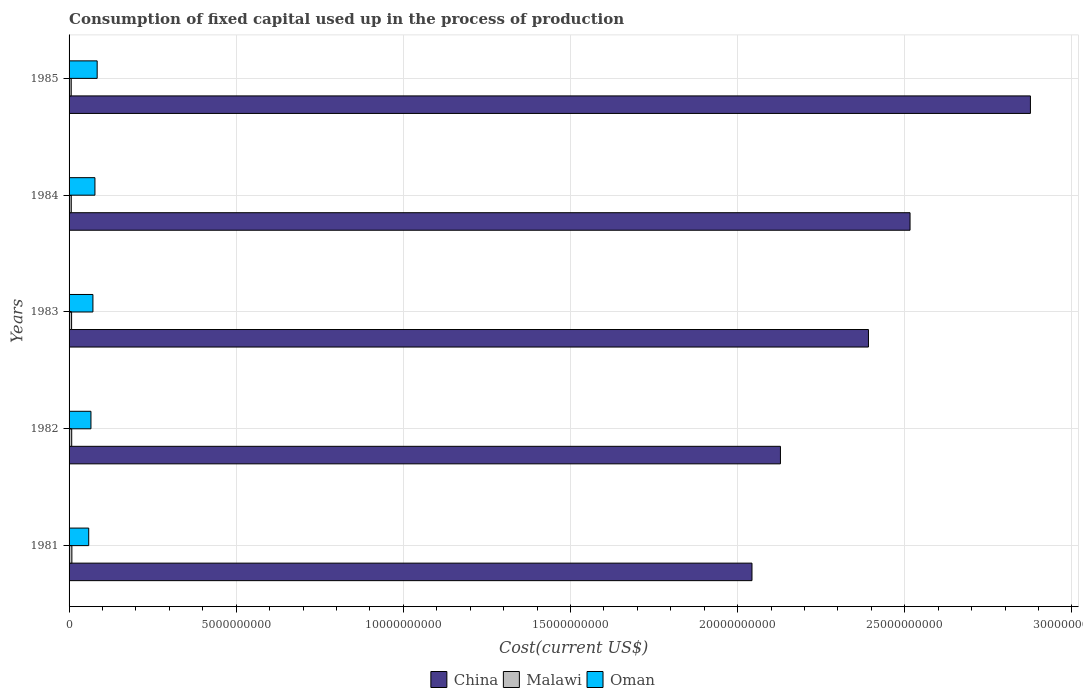How many different coloured bars are there?
Your answer should be compact. 3. In how many cases, is the number of bars for a given year not equal to the number of legend labels?
Your answer should be very brief. 0. What is the amount consumed in the process of production in Malawi in 1982?
Your response must be concise. 7.87e+07. Across all years, what is the maximum amount consumed in the process of production in Malawi?
Offer a very short reply. 8.38e+07. Across all years, what is the minimum amount consumed in the process of production in Malawi?
Give a very brief answer. 6.42e+07. In which year was the amount consumed in the process of production in Malawi maximum?
Give a very brief answer. 1981. In which year was the amount consumed in the process of production in Oman minimum?
Keep it short and to the point. 1981. What is the total amount consumed in the process of production in Malawi in the graph?
Your response must be concise. 3.68e+08. What is the difference between the amount consumed in the process of production in Malawi in 1981 and that in 1983?
Provide a short and direct response. 8.38e+06. What is the difference between the amount consumed in the process of production in China in 1981 and the amount consumed in the process of production in Malawi in 1984?
Your answer should be compact. 2.04e+1. What is the average amount consumed in the process of production in Malawi per year?
Keep it short and to the point. 7.35e+07. In the year 1985, what is the difference between the amount consumed in the process of production in Malawi and amount consumed in the process of production in Oman?
Your answer should be compact. -7.76e+08. What is the ratio of the amount consumed in the process of production in China in 1982 to that in 1985?
Your response must be concise. 0.74. Is the amount consumed in the process of production in Malawi in 1983 less than that in 1985?
Your answer should be compact. No. What is the difference between the highest and the second highest amount consumed in the process of production in Oman?
Provide a short and direct response. 6.71e+07. What is the difference between the highest and the lowest amount consumed in the process of production in China?
Provide a short and direct response. 8.33e+09. Is the sum of the amount consumed in the process of production in Oman in 1984 and 1985 greater than the maximum amount consumed in the process of production in China across all years?
Your response must be concise. No. What does the 2nd bar from the top in 1985 represents?
Give a very brief answer. Malawi. Are all the bars in the graph horizontal?
Your answer should be compact. Yes. What is the difference between two consecutive major ticks on the X-axis?
Keep it short and to the point. 5.00e+09. Does the graph contain any zero values?
Offer a terse response. No. How many legend labels are there?
Your answer should be compact. 3. How are the legend labels stacked?
Make the answer very short. Horizontal. What is the title of the graph?
Give a very brief answer. Consumption of fixed capital used up in the process of production. Does "Jamaica" appear as one of the legend labels in the graph?
Provide a succinct answer. No. What is the label or title of the X-axis?
Your response must be concise. Cost(current US$). What is the label or title of the Y-axis?
Your answer should be very brief. Years. What is the Cost(current US$) of China in 1981?
Your response must be concise. 2.04e+1. What is the Cost(current US$) in Malawi in 1981?
Offer a terse response. 8.38e+07. What is the Cost(current US$) in Oman in 1981?
Your answer should be very brief. 5.88e+08. What is the Cost(current US$) in China in 1982?
Give a very brief answer. 2.13e+1. What is the Cost(current US$) of Malawi in 1982?
Provide a short and direct response. 7.87e+07. What is the Cost(current US$) of Oman in 1982?
Give a very brief answer. 6.54e+08. What is the Cost(current US$) of China in 1983?
Your response must be concise. 2.39e+1. What is the Cost(current US$) in Malawi in 1983?
Offer a terse response. 7.54e+07. What is the Cost(current US$) in Oman in 1983?
Offer a terse response. 7.13e+08. What is the Cost(current US$) of China in 1984?
Keep it short and to the point. 2.52e+1. What is the Cost(current US$) of Malawi in 1984?
Provide a succinct answer. 6.57e+07. What is the Cost(current US$) in Oman in 1984?
Give a very brief answer. 7.74e+08. What is the Cost(current US$) in China in 1985?
Offer a terse response. 2.88e+1. What is the Cost(current US$) in Malawi in 1985?
Offer a terse response. 6.42e+07. What is the Cost(current US$) in Oman in 1985?
Offer a very short reply. 8.41e+08. Across all years, what is the maximum Cost(current US$) of China?
Provide a short and direct response. 2.88e+1. Across all years, what is the maximum Cost(current US$) of Malawi?
Offer a terse response. 8.38e+07. Across all years, what is the maximum Cost(current US$) of Oman?
Make the answer very short. 8.41e+08. Across all years, what is the minimum Cost(current US$) in China?
Your answer should be compact. 2.04e+1. Across all years, what is the minimum Cost(current US$) of Malawi?
Provide a short and direct response. 6.42e+07. Across all years, what is the minimum Cost(current US$) in Oman?
Provide a short and direct response. 5.88e+08. What is the total Cost(current US$) in China in the graph?
Give a very brief answer. 1.20e+11. What is the total Cost(current US$) in Malawi in the graph?
Your answer should be very brief. 3.68e+08. What is the total Cost(current US$) of Oman in the graph?
Keep it short and to the point. 3.57e+09. What is the difference between the Cost(current US$) of China in 1981 and that in 1982?
Offer a very short reply. -8.51e+08. What is the difference between the Cost(current US$) of Malawi in 1981 and that in 1982?
Ensure brevity in your answer.  5.11e+06. What is the difference between the Cost(current US$) in Oman in 1981 and that in 1982?
Offer a very short reply. -6.68e+07. What is the difference between the Cost(current US$) in China in 1981 and that in 1983?
Provide a succinct answer. -3.48e+09. What is the difference between the Cost(current US$) of Malawi in 1981 and that in 1983?
Your response must be concise. 8.38e+06. What is the difference between the Cost(current US$) of Oman in 1981 and that in 1983?
Your answer should be compact. -1.26e+08. What is the difference between the Cost(current US$) in China in 1981 and that in 1984?
Ensure brevity in your answer.  -4.73e+09. What is the difference between the Cost(current US$) of Malawi in 1981 and that in 1984?
Offer a terse response. 1.81e+07. What is the difference between the Cost(current US$) of Oman in 1981 and that in 1984?
Ensure brevity in your answer.  -1.86e+08. What is the difference between the Cost(current US$) of China in 1981 and that in 1985?
Your answer should be very brief. -8.33e+09. What is the difference between the Cost(current US$) of Malawi in 1981 and that in 1985?
Provide a short and direct response. 1.96e+07. What is the difference between the Cost(current US$) in Oman in 1981 and that in 1985?
Provide a short and direct response. -2.53e+08. What is the difference between the Cost(current US$) in China in 1982 and that in 1983?
Your answer should be very brief. -2.63e+09. What is the difference between the Cost(current US$) of Malawi in 1982 and that in 1983?
Ensure brevity in your answer.  3.27e+06. What is the difference between the Cost(current US$) in Oman in 1982 and that in 1983?
Make the answer very short. -5.90e+07. What is the difference between the Cost(current US$) in China in 1982 and that in 1984?
Your answer should be compact. -3.88e+09. What is the difference between the Cost(current US$) in Malawi in 1982 and that in 1984?
Make the answer very short. 1.30e+07. What is the difference between the Cost(current US$) in Oman in 1982 and that in 1984?
Offer a very short reply. -1.19e+08. What is the difference between the Cost(current US$) in China in 1982 and that in 1985?
Give a very brief answer. -7.48e+09. What is the difference between the Cost(current US$) in Malawi in 1982 and that in 1985?
Your answer should be compact. 1.44e+07. What is the difference between the Cost(current US$) in Oman in 1982 and that in 1985?
Provide a short and direct response. -1.86e+08. What is the difference between the Cost(current US$) of China in 1983 and that in 1984?
Ensure brevity in your answer.  -1.24e+09. What is the difference between the Cost(current US$) in Malawi in 1983 and that in 1984?
Your answer should be very brief. 9.69e+06. What is the difference between the Cost(current US$) in Oman in 1983 and that in 1984?
Provide a succinct answer. -6.01e+07. What is the difference between the Cost(current US$) in China in 1983 and that in 1985?
Your response must be concise. -4.85e+09. What is the difference between the Cost(current US$) in Malawi in 1983 and that in 1985?
Ensure brevity in your answer.  1.12e+07. What is the difference between the Cost(current US$) in Oman in 1983 and that in 1985?
Make the answer very short. -1.27e+08. What is the difference between the Cost(current US$) in China in 1984 and that in 1985?
Offer a terse response. -3.60e+09. What is the difference between the Cost(current US$) in Malawi in 1984 and that in 1985?
Your answer should be very brief. 1.49e+06. What is the difference between the Cost(current US$) of Oman in 1984 and that in 1985?
Your answer should be very brief. -6.71e+07. What is the difference between the Cost(current US$) in China in 1981 and the Cost(current US$) in Malawi in 1982?
Provide a short and direct response. 2.03e+1. What is the difference between the Cost(current US$) of China in 1981 and the Cost(current US$) of Oman in 1982?
Give a very brief answer. 1.98e+1. What is the difference between the Cost(current US$) of Malawi in 1981 and the Cost(current US$) of Oman in 1982?
Your answer should be very brief. -5.71e+08. What is the difference between the Cost(current US$) in China in 1981 and the Cost(current US$) in Malawi in 1983?
Offer a very short reply. 2.04e+1. What is the difference between the Cost(current US$) of China in 1981 and the Cost(current US$) of Oman in 1983?
Provide a succinct answer. 1.97e+1. What is the difference between the Cost(current US$) in Malawi in 1981 and the Cost(current US$) in Oman in 1983?
Provide a short and direct response. -6.30e+08. What is the difference between the Cost(current US$) in China in 1981 and the Cost(current US$) in Malawi in 1984?
Your answer should be very brief. 2.04e+1. What is the difference between the Cost(current US$) in China in 1981 and the Cost(current US$) in Oman in 1984?
Your response must be concise. 1.97e+1. What is the difference between the Cost(current US$) of Malawi in 1981 and the Cost(current US$) of Oman in 1984?
Your answer should be compact. -6.90e+08. What is the difference between the Cost(current US$) of China in 1981 and the Cost(current US$) of Malawi in 1985?
Offer a very short reply. 2.04e+1. What is the difference between the Cost(current US$) in China in 1981 and the Cost(current US$) in Oman in 1985?
Make the answer very short. 1.96e+1. What is the difference between the Cost(current US$) of Malawi in 1981 and the Cost(current US$) of Oman in 1985?
Provide a succinct answer. -7.57e+08. What is the difference between the Cost(current US$) of China in 1982 and the Cost(current US$) of Malawi in 1983?
Give a very brief answer. 2.12e+1. What is the difference between the Cost(current US$) of China in 1982 and the Cost(current US$) of Oman in 1983?
Offer a terse response. 2.06e+1. What is the difference between the Cost(current US$) in Malawi in 1982 and the Cost(current US$) in Oman in 1983?
Your response must be concise. -6.35e+08. What is the difference between the Cost(current US$) in China in 1982 and the Cost(current US$) in Malawi in 1984?
Your answer should be compact. 2.12e+1. What is the difference between the Cost(current US$) of China in 1982 and the Cost(current US$) of Oman in 1984?
Your answer should be compact. 2.05e+1. What is the difference between the Cost(current US$) of Malawi in 1982 and the Cost(current US$) of Oman in 1984?
Keep it short and to the point. -6.95e+08. What is the difference between the Cost(current US$) of China in 1982 and the Cost(current US$) of Malawi in 1985?
Provide a short and direct response. 2.12e+1. What is the difference between the Cost(current US$) in China in 1982 and the Cost(current US$) in Oman in 1985?
Keep it short and to the point. 2.04e+1. What is the difference between the Cost(current US$) in Malawi in 1982 and the Cost(current US$) in Oman in 1985?
Provide a succinct answer. -7.62e+08. What is the difference between the Cost(current US$) of China in 1983 and the Cost(current US$) of Malawi in 1984?
Offer a terse response. 2.38e+1. What is the difference between the Cost(current US$) in China in 1983 and the Cost(current US$) in Oman in 1984?
Your answer should be compact. 2.31e+1. What is the difference between the Cost(current US$) in Malawi in 1983 and the Cost(current US$) in Oman in 1984?
Make the answer very short. -6.98e+08. What is the difference between the Cost(current US$) of China in 1983 and the Cost(current US$) of Malawi in 1985?
Keep it short and to the point. 2.38e+1. What is the difference between the Cost(current US$) of China in 1983 and the Cost(current US$) of Oman in 1985?
Your answer should be very brief. 2.31e+1. What is the difference between the Cost(current US$) of Malawi in 1983 and the Cost(current US$) of Oman in 1985?
Offer a very short reply. -7.65e+08. What is the difference between the Cost(current US$) of China in 1984 and the Cost(current US$) of Malawi in 1985?
Your answer should be compact. 2.51e+1. What is the difference between the Cost(current US$) of China in 1984 and the Cost(current US$) of Oman in 1985?
Your answer should be compact. 2.43e+1. What is the difference between the Cost(current US$) in Malawi in 1984 and the Cost(current US$) in Oman in 1985?
Offer a very short reply. -7.75e+08. What is the average Cost(current US$) of China per year?
Your answer should be very brief. 2.39e+1. What is the average Cost(current US$) in Malawi per year?
Provide a short and direct response. 7.35e+07. What is the average Cost(current US$) of Oman per year?
Offer a very short reply. 7.14e+08. In the year 1981, what is the difference between the Cost(current US$) in China and Cost(current US$) in Malawi?
Your answer should be very brief. 2.03e+1. In the year 1981, what is the difference between the Cost(current US$) in China and Cost(current US$) in Oman?
Offer a very short reply. 1.98e+1. In the year 1981, what is the difference between the Cost(current US$) of Malawi and Cost(current US$) of Oman?
Provide a succinct answer. -5.04e+08. In the year 1982, what is the difference between the Cost(current US$) in China and Cost(current US$) in Malawi?
Your response must be concise. 2.12e+1. In the year 1982, what is the difference between the Cost(current US$) in China and Cost(current US$) in Oman?
Your answer should be compact. 2.06e+1. In the year 1982, what is the difference between the Cost(current US$) of Malawi and Cost(current US$) of Oman?
Your answer should be very brief. -5.76e+08. In the year 1983, what is the difference between the Cost(current US$) of China and Cost(current US$) of Malawi?
Offer a terse response. 2.38e+1. In the year 1983, what is the difference between the Cost(current US$) of China and Cost(current US$) of Oman?
Offer a terse response. 2.32e+1. In the year 1983, what is the difference between the Cost(current US$) of Malawi and Cost(current US$) of Oman?
Give a very brief answer. -6.38e+08. In the year 1984, what is the difference between the Cost(current US$) in China and Cost(current US$) in Malawi?
Your answer should be very brief. 2.51e+1. In the year 1984, what is the difference between the Cost(current US$) in China and Cost(current US$) in Oman?
Your answer should be very brief. 2.44e+1. In the year 1984, what is the difference between the Cost(current US$) of Malawi and Cost(current US$) of Oman?
Provide a succinct answer. -7.08e+08. In the year 1985, what is the difference between the Cost(current US$) of China and Cost(current US$) of Malawi?
Provide a short and direct response. 2.87e+1. In the year 1985, what is the difference between the Cost(current US$) in China and Cost(current US$) in Oman?
Your answer should be compact. 2.79e+1. In the year 1985, what is the difference between the Cost(current US$) of Malawi and Cost(current US$) of Oman?
Offer a terse response. -7.76e+08. What is the ratio of the Cost(current US$) in Malawi in 1981 to that in 1982?
Provide a short and direct response. 1.06. What is the ratio of the Cost(current US$) in Oman in 1981 to that in 1982?
Ensure brevity in your answer.  0.9. What is the ratio of the Cost(current US$) in China in 1981 to that in 1983?
Provide a short and direct response. 0.85. What is the ratio of the Cost(current US$) of Malawi in 1981 to that in 1983?
Provide a short and direct response. 1.11. What is the ratio of the Cost(current US$) of Oman in 1981 to that in 1983?
Ensure brevity in your answer.  0.82. What is the ratio of the Cost(current US$) of China in 1981 to that in 1984?
Your answer should be very brief. 0.81. What is the ratio of the Cost(current US$) in Malawi in 1981 to that in 1984?
Your answer should be very brief. 1.27. What is the ratio of the Cost(current US$) of Oman in 1981 to that in 1984?
Provide a succinct answer. 0.76. What is the ratio of the Cost(current US$) in China in 1981 to that in 1985?
Provide a succinct answer. 0.71. What is the ratio of the Cost(current US$) in Malawi in 1981 to that in 1985?
Offer a terse response. 1.3. What is the ratio of the Cost(current US$) of Oman in 1981 to that in 1985?
Your answer should be very brief. 0.7. What is the ratio of the Cost(current US$) in China in 1982 to that in 1983?
Your answer should be compact. 0.89. What is the ratio of the Cost(current US$) in Malawi in 1982 to that in 1983?
Your response must be concise. 1.04. What is the ratio of the Cost(current US$) in Oman in 1982 to that in 1983?
Ensure brevity in your answer.  0.92. What is the ratio of the Cost(current US$) of China in 1982 to that in 1984?
Your answer should be very brief. 0.85. What is the ratio of the Cost(current US$) of Malawi in 1982 to that in 1984?
Your answer should be compact. 1.2. What is the ratio of the Cost(current US$) in Oman in 1982 to that in 1984?
Keep it short and to the point. 0.85. What is the ratio of the Cost(current US$) in China in 1982 to that in 1985?
Your answer should be compact. 0.74. What is the ratio of the Cost(current US$) of Malawi in 1982 to that in 1985?
Ensure brevity in your answer.  1.23. What is the ratio of the Cost(current US$) in Oman in 1982 to that in 1985?
Provide a succinct answer. 0.78. What is the ratio of the Cost(current US$) of China in 1983 to that in 1984?
Offer a terse response. 0.95. What is the ratio of the Cost(current US$) of Malawi in 1983 to that in 1984?
Your answer should be very brief. 1.15. What is the ratio of the Cost(current US$) of Oman in 1983 to that in 1984?
Your response must be concise. 0.92. What is the ratio of the Cost(current US$) in China in 1983 to that in 1985?
Make the answer very short. 0.83. What is the ratio of the Cost(current US$) in Malawi in 1983 to that in 1985?
Provide a short and direct response. 1.17. What is the ratio of the Cost(current US$) in Oman in 1983 to that in 1985?
Your answer should be very brief. 0.85. What is the ratio of the Cost(current US$) in China in 1984 to that in 1985?
Offer a terse response. 0.87. What is the ratio of the Cost(current US$) of Malawi in 1984 to that in 1985?
Ensure brevity in your answer.  1.02. What is the ratio of the Cost(current US$) in Oman in 1984 to that in 1985?
Keep it short and to the point. 0.92. What is the difference between the highest and the second highest Cost(current US$) in China?
Make the answer very short. 3.60e+09. What is the difference between the highest and the second highest Cost(current US$) of Malawi?
Your response must be concise. 5.11e+06. What is the difference between the highest and the second highest Cost(current US$) in Oman?
Ensure brevity in your answer.  6.71e+07. What is the difference between the highest and the lowest Cost(current US$) of China?
Provide a short and direct response. 8.33e+09. What is the difference between the highest and the lowest Cost(current US$) of Malawi?
Give a very brief answer. 1.96e+07. What is the difference between the highest and the lowest Cost(current US$) in Oman?
Make the answer very short. 2.53e+08. 